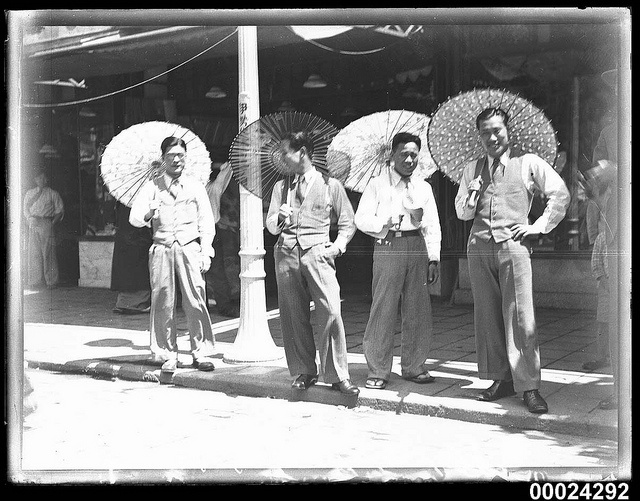Describe the objects in this image and their specific colors. I can see people in black, gray, lightgray, and darkgray tones, people in black, gray, lightgray, and darkgray tones, people in black, gray, and white tones, people in black, white, darkgray, and gray tones, and umbrella in black, darkgray, gray, and lightgray tones in this image. 